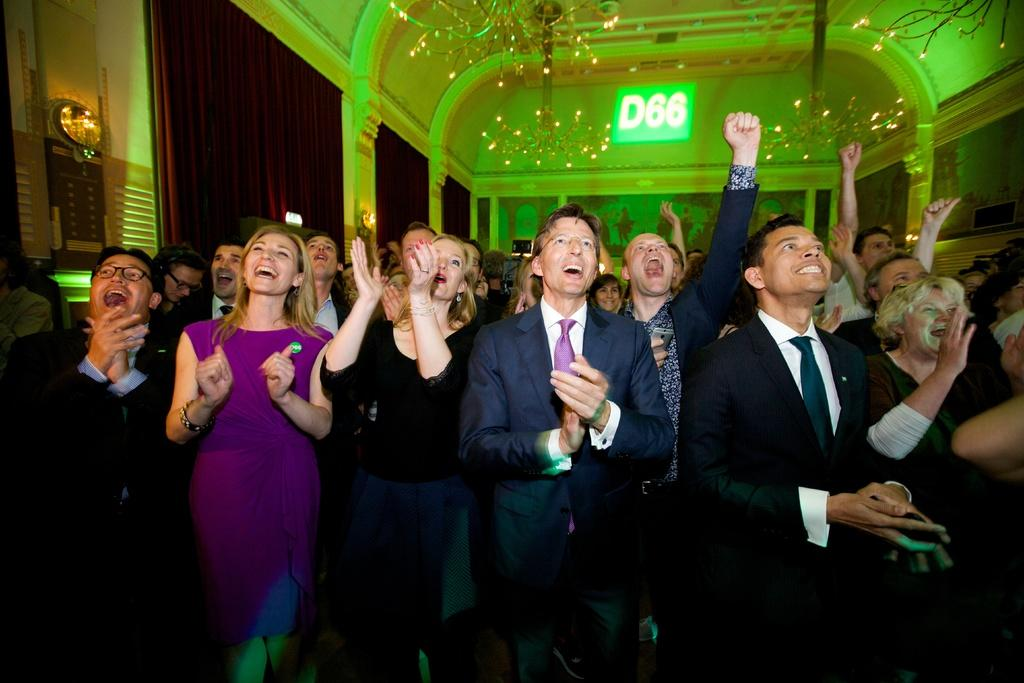What is happening in the image involving the group of people? The people in the image are laughing. Can you describe any specific features of the people in the group? Some people in the group are wearing spectacles. What can be seen in the background of the image? There are lights and curtains visible in the background of the image. What type of fish can be seen participating in the protest in the image? There are no fish or protests present in the image; it features a group of people laughing. What kind of cart is visible in the background of the image? There is no cart visible in the background of the image; it features lights and curtains. 